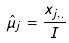<formula> <loc_0><loc_0><loc_500><loc_500>\hat { \mu } _ { j } = \frac { x _ { j , . } } { I }</formula> 